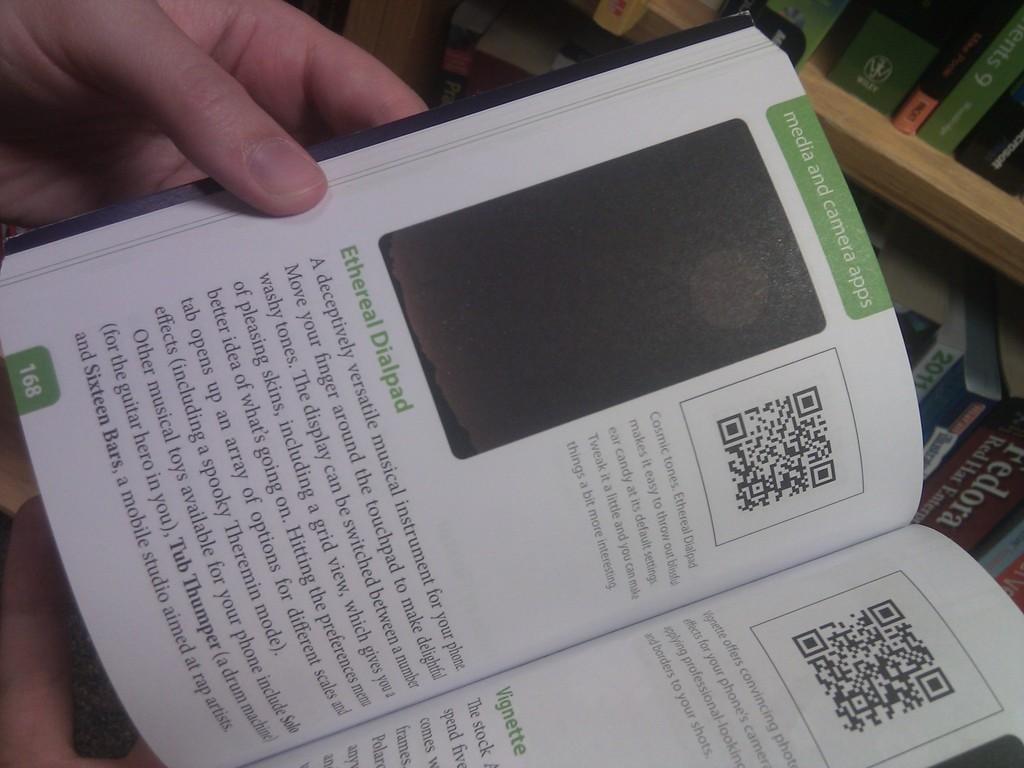<image>
Render a clear and concise summary of the photo. the inside of a book with the page titled: media and camera apps 